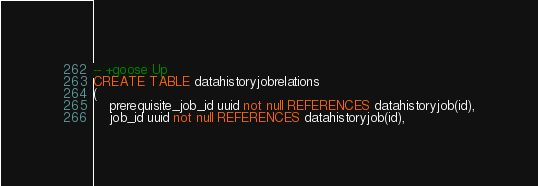Convert code to text. <code><loc_0><loc_0><loc_500><loc_500><_SQL_>-- +goose Up
CREATE TABLE datahistoryjobrelations
(
    prerequisite_job_id uuid not null REFERENCES datahistoryjob(id),
    job_id uuid not null REFERENCES datahistoryjob(id),</code> 